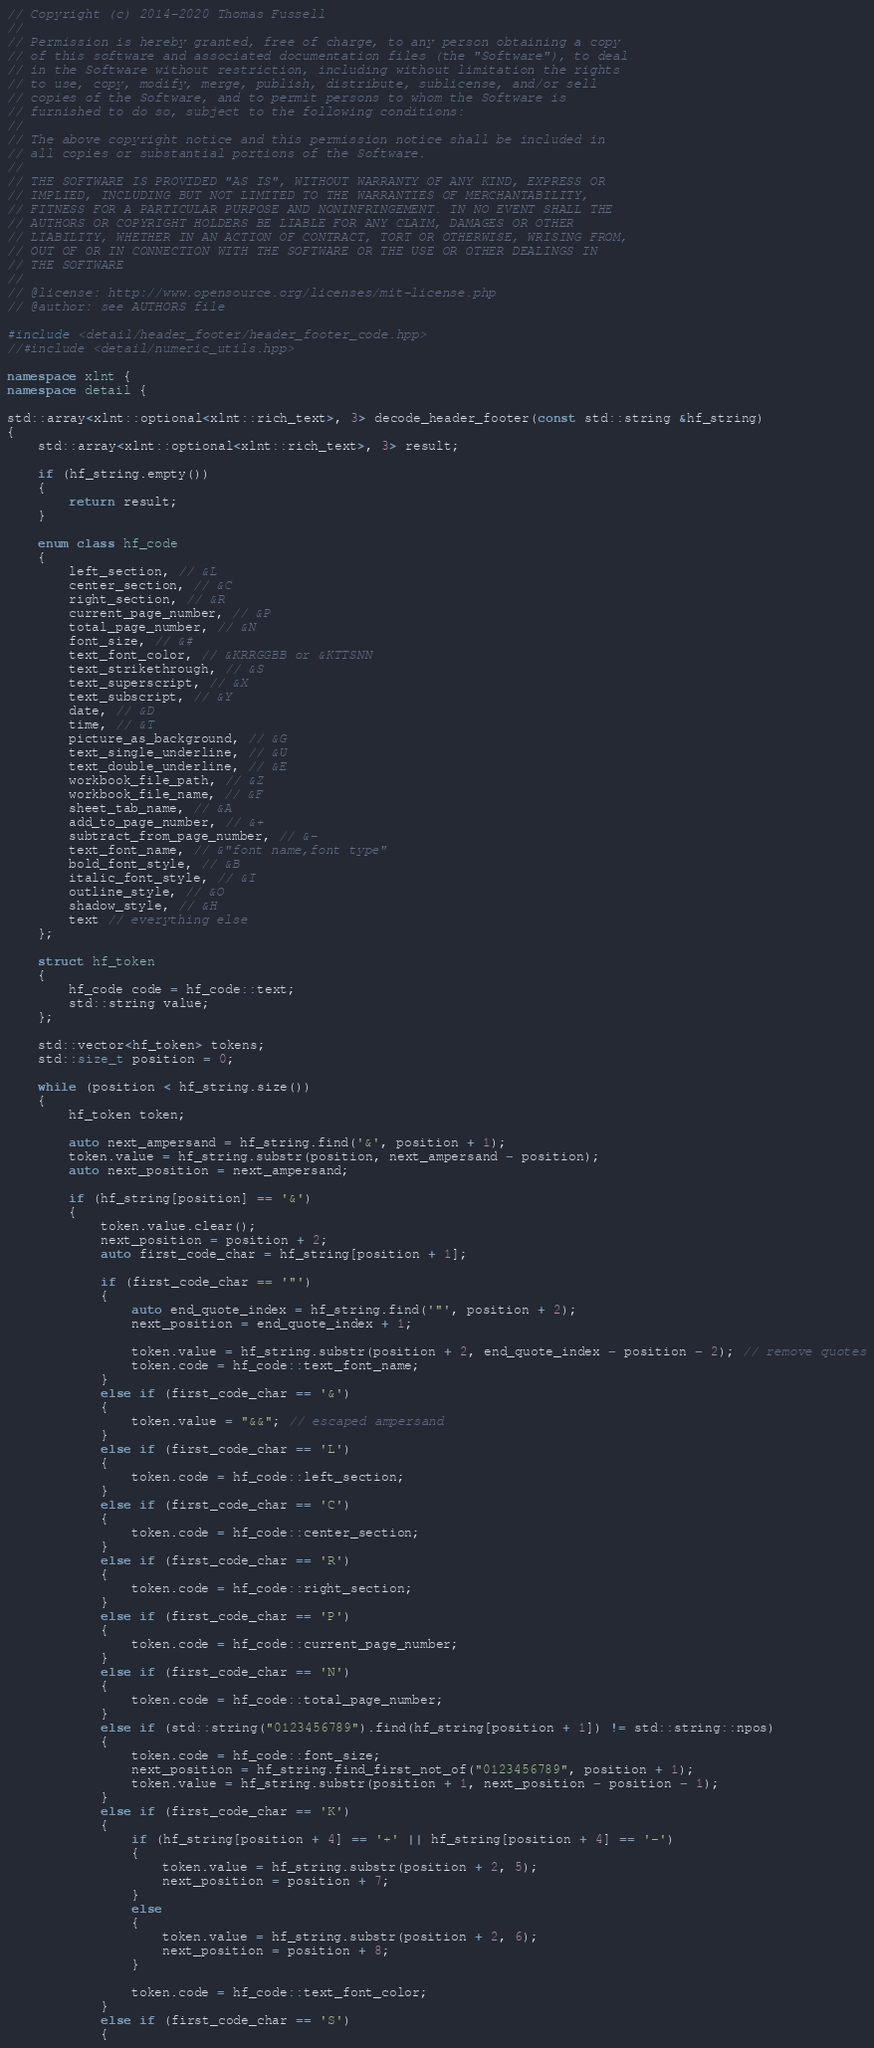Convert code to text. <code><loc_0><loc_0><loc_500><loc_500><_C++_>// Copyright (c) 2014-2020 Thomas Fussell
//
// Permission is hereby granted, free of charge, to any person obtaining a copy
// of this software and associated documentation files (the "Software"), to deal
// in the Software without restriction, including without limitation the rights
// to use, copy, modify, merge, publish, distribute, sublicense, and/or sell
// copies of the Software, and to permit persons to whom the Software is
// furnished to do so, subject to the following conditions:
//
// The above copyright notice and this permission notice shall be included in
// all copies or substantial portions of the Software.
//
// THE SOFTWARE IS PROVIDED "AS IS", WITHOUT WARRANTY OF ANY KIND, EXPRESS OR
// IMPLIED, INCLUDING BUT NOT LIMITED TO THE WARRANTIES OF MERCHANTABILITY,
// FITNESS FOR A PARTICULAR PURPOSE AND NONINFRINGEMENT. IN NO EVENT SHALL THE
// AUTHORS OR COPYRIGHT HOLDERS BE LIABLE FOR ANY CLAIM, DAMAGES OR OTHER
// LIABILITY, WHETHER IN AN ACTION OF CONTRACT, TORT OR OTHERWISE, WRISING FROM,
// OUT OF OR IN CONNECTION WITH THE SOFTWARE OR THE USE OR OTHER DEALINGS IN
// THE SOFTWARE
//
// @license: http://www.opensource.org/licenses/mit-license.php
// @author: see AUTHORS file

#include <detail/header_footer/header_footer_code.hpp>
//#include <detail/numeric_utils.hpp>

namespace xlnt {
namespace detail {

std::array<xlnt::optional<xlnt::rich_text>, 3> decode_header_footer(const std::string &hf_string)
{
    std::array<xlnt::optional<xlnt::rich_text>, 3> result;

    if (hf_string.empty())
    {
        return result;
    }

    enum class hf_code
    {
        left_section, // &L
        center_section, // &C
        right_section, // &R
        current_page_number, // &P
        total_page_number, // &N
        font_size, // &#
        text_font_color, // &KRRGGBB or &KTTSNN
        text_strikethrough, // &S
        text_superscript, // &X
        text_subscript, // &Y
        date, // &D
        time, // &T
        picture_as_background, // &G
        text_single_underline, // &U
        text_double_underline, // &E
        workbook_file_path, // &Z
        workbook_file_name, // &F
        sheet_tab_name, // &A
        add_to_page_number, // &+
        subtract_from_page_number, // &-
        text_font_name, // &"font name,font type"
        bold_font_style, // &B
        italic_font_style, // &I
        outline_style, // &O
        shadow_style, // &H
        text // everything else
    };

    struct hf_token
    {
        hf_code code = hf_code::text;
        std::string value;
    };

    std::vector<hf_token> tokens;
    std::size_t position = 0;

    while (position < hf_string.size())
    {
        hf_token token;

        auto next_ampersand = hf_string.find('&', position + 1);
        token.value = hf_string.substr(position, next_ampersand - position);
        auto next_position = next_ampersand;

        if (hf_string[position] == '&')
        {
            token.value.clear();
            next_position = position + 2;
            auto first_code_char = hf_string[position + 1];

            if (first_code_char == '"')
            {
                auto end_quote_index = hf_string.find('"', position + 2);
                next_position = end_quote_index + 1;

                token.value = hf_string.substr(position + 2, end_quote_index - position - 2); // remove quotes
                token.code = hf_code::text_font_name;
            }
            else if (first_code_char == '&')
            {
                token.value = "&&"; // escaped ampersand
            }
            else if (first_code_char == 'L')
            {
                token.code = hf_code::left_section;
            }
            else if (first_code_char == 'C')
            {
                token.code = hf_code::center_section;
            }
            else if (first_code_char == 'R')
            {
                token.code = hf_code::right_section;
            }
            else if (first_code_char == 'P')
            {
                token.code = hf_code::current_page_number;
            }
            else if (first_code_char == 'N')
            {
                token.code = hf_code::total_page_number;
            }
            else if (std::string("0123456789").find(hf_string[position + 1]) != std::string::npos)
            {
                token.code = hf_code::font_size;
                next_position = hf_string.find_first_not_of("0123456789", position + 1);
                token.value = hf_string.substr(position + 1, next_position - position - 1);
            }
            else if (first_code_char == 'K')
            {
                if (hf_string[position + 4] == '+' || hf_string[position + 4] == '-')
                {
                    token.value = hf_string.substr(position + 2, 5);
                    next_position = position + 7;
                }
                else
                {
                    token.value = hf_string.substr(position + 2, 6);
                    next_position = position + 8;
                }

                token.code = hf_code::text_font_color;
            }
            else if (first_code_char == 'S')
            {</code> 